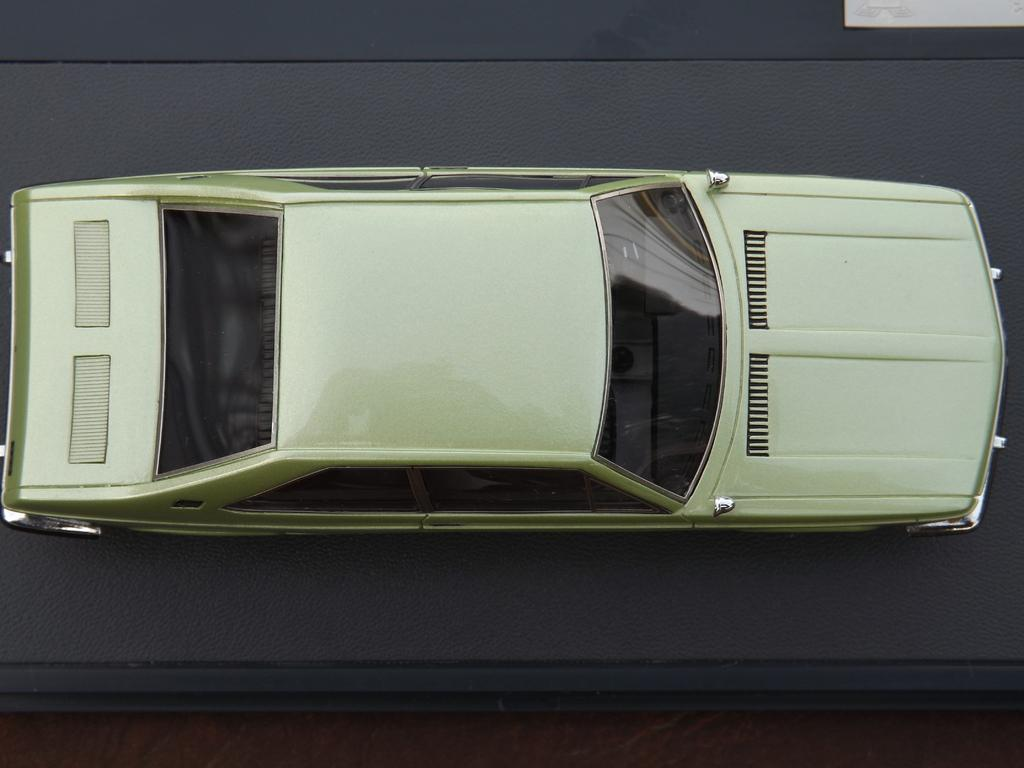What is the main subject of the image? The main subject of the image is a car. Can you describe the color of the car? The car is cream-colored. What type of surface is the car on? The car is on a gray surface. What type of oatmeal is being prepared in the car's trunk in the image? There is no oatmeal or any cooking activity present in the image; it only features a cream-colored car on a gray surface. 